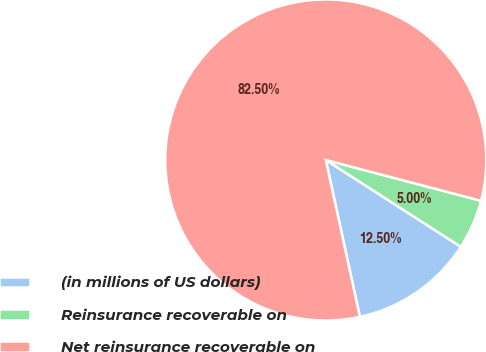Convert chart to OTSL. <chart><loc_0><loc_0><loc_500><loc_500><pie_chart><fcel>(in millions of US dollars)<fcel>Reinsurance recoverable on<fcel>Net reinsurance recoverable on<nl><fcel>12.5%<fcel>5.0%<fcel>82.5%<nl></chart> 